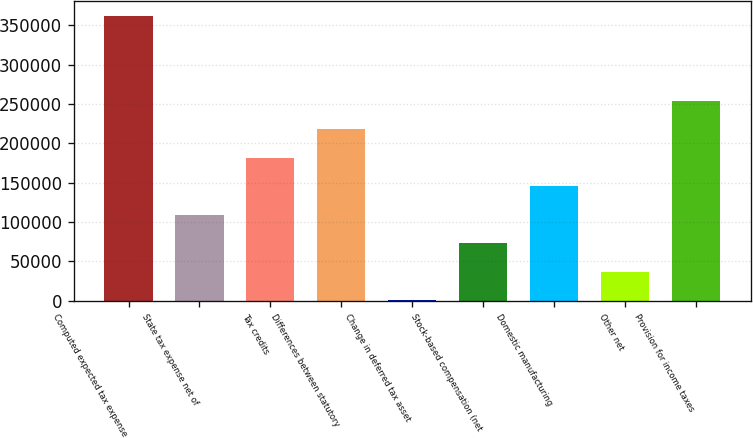<chart> <loc_0><loc_0><loc_500><loc_500><bar_chart><fcel>Computed expected tax expense<fcel>State tax expense net of<fcel>Tax credits<fcel>Differences between statutory<fcel>Change in deferred tax asset<fcel>Stock-based compensation (net<fcel>Domestic manufacturing<fcel>Other net<fcel>Provision for income taxes<nl><fcel>362331<fcel>109044<fcel>181412<fcel>217596<fcel>493<fcel>72860.6<fcel>145228<fcel>36676.8<fcel>253780<nl></chart> 